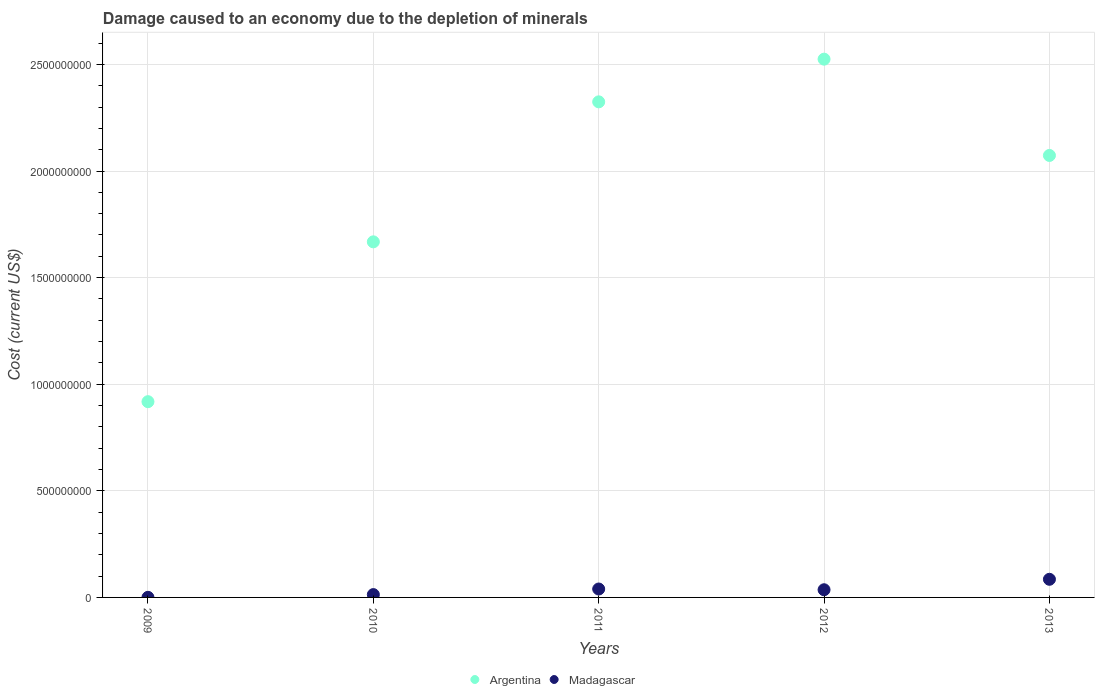What is the cost of damage caused due to the depletion of minerals in Madagascar in 2009?
Offer a terse response. 4.19e+05. Across all years, what is the maximum cost of damage caused due to the depletion of minerals in Madagascar?
Your answer should be very brief. 8.50e+07. Across all years, what is the minimum cost of damage caused due to the depletion of minerals in Argentina?
Your answer should be compact. 9.18e+08. In which year was the cost of damage caused due to the depletion of minerals in Argentina maximum?
Your answer should be compact. 2012. In which year was the cost of damage caused due to the depletion of minerals in Madagascar minimum?
Your answer should be very brief. 2009. What is the total cost of damage caused due to the depletion of minerals in Madagascar in the graph?
Your response must be concise. 1.74e+08. What is the difference between the cost of damage caused due to the depletion of minerals in Argentina in 2009 and that in 2013?
Your answer should be very brief. -1.15e+09. What is the difference between the cost of damage caused due to the depletion of minerals in Madagascar in 2010 and the cost of damage caused due to the depletion of minerals in Argentina in 2009?
Ensure brevity in your answer.  -9.05e+08. What is the average cost of damage caused due to the depletion of minerals in Madagascar per year?
Your response must be concise. 3.48e+07. In the year 2009, what is the difference between the cost of damage caused due to the depletion of minerals in Madagascar and cost of damage caused due to the depletion of minerals in Argentina?
Ensure brevity in your answer.  -9.18e+08. In how many years, is the cost of damage caused due to the depletion of minerals in Argentina greater than 2200000000 US$?
Your response must be concise. 2. What is the ratio of the cost of damage caused due to the depletion of minerals in Argentina in 2009 to that in 2011?
Your response must be concise. 0.39. Is the difference between the cost of damage caused due to the depletion of minerals in Madagascar in 2011 and 2013 greater than the difference between the cost of damage caused due to the depletion of minerals in Argentina in 2011 and 2013?
Give a very brief answer. No. What is the difference between the highest and the second highest cost of damage caused due to the depletion of minerals in Argentina?
Ensure brevity in your answer.  2.00e+08. What is the difference between the highest and the lowest cost of damage caused due to the depletion of minerals in Madagascar?
Make the answer very short. 8.46e+07. Is the sum of the cost of damage caused due to the depletion of minerals in Argentina in 2009 and 2011 greater than the maximum cost of damage caused due to the depletion of minerals in Madagascar across all years?
Offer a terse response. Yes. Does the cost of damage caused due to the depletion of minerals in Madagascar monotonically increase over the years?
Offer a very short reply. No. Is the cost of damage caused due to the depletion of minerals in Madagascar strictly less than the cost of damage caused due to the depletion of minerals in Argentina over the years?
Give a very brief answer. Yes. What is the difference between two consecutive major ticks on the Y-axis?
Your answer should be very brief. 5.00e+08. Does the graph contain grids?
Offer a terse response. Yes. What is the title of the graph?
Offer a very short reply. Damage caused to an economy due to the depletion of minerals. What is the label or title of the Y-axis?
Your answer should be very brief. Cost (current US$). What is the Cost (current US$) in Argentina in 2009?
Make the answer very short. 9.18e+08. What is the Cost (current US$) of Madagascar in 2009?
Provide a short and direct response. 4.19e+05. What is the Cost (current US$) of Argentina in 2010?
Keep it short and to the point. 1.67e+09. What is the Cost (current US$) of Madagascar in 2010?
Keep it short and to the point. 1.33e+07. What is the Cost (current US$) of Argentina in 2011?
Provide a short and direct response. 2.32e+09. What is the Cost (current US$) in Madagascar in 2011?
Keep it short and to the point. 3.95e+07. What is the Cost (current US$) in Argentina in 2012?
Provide a short and direct response. 2.52e+09. What is the Cost (current US$) of Madagascar in 2012?
Your answer should be very brief. 3.60e+07. What is the Cost (current US$) of Argentina in 2013?
Make the answer very short. 2.07e+09. What is the Cost (current US$) of Madagascar in 2013?
Make the answer very short. 8.50e+07. Across all years, what is the maximum Cost (current US$) in Argentina?
Ensure brevity in your answer.  2.52e+09. Across all years, what is the maximum Cost (current US$) in Madagascar?
Offer a very short reply. 8.50e+07. Across all years, what is the minimum Cost (current US$) in Argentina?
Ensure brevity in your answer.  9.18e+08. Across all years, what is the minimum Cost (current US$) of Madagascar?
Provide a short and direct response. 4.19e+05. What is the total Cost (current US$) of Argentina in the graph?
Your answer should be very brief. 9.51e+09. What is the total Cost (current US$) in Madagascar in the graph?
Offer a very short reply. 1.74e+08. What is the difference between the Cost (current US$) in Argentina in 2009 and that in 2010?
Offer a terse response. -7.50e+08. What is the difference between the Cost (current US$) of Madagascar in 2009 and that in 2010?
Ensure brevity in your answer.  -1.29e+07. What is the difference between the Cost (current US$) of Argentina in 2009 and that in 2011?
Offer a very short reply. -1.41e+09. What is the difference between the Cost (current US$) of Madagascar in 2009 and that in 2011?
Provide a short and direct response. -3.91e+07. What is the difference between the Cost (current US$) of Argentina in 2009 and that in 2012?
Offer a very short reply. -1.61e+09. What is the difference between the Cost (current US$) in Madagascar in 2009 and that in 2012?
Offer a very short reply. -3.56e+07. What is the difference between the Cost (current US$) of Argentina in 2009 and that in 2013?
Provide a short and direct response. -1.15e+09. What is the difference between the Cost (current US$) of Madagascar in 2009 and that in 2013?
Provide a short and direct response. -8.46e+07. What is the difference between the Cost (current US$) of Argentina in 2010 and that in 2011?
Ensure brevity in your answer.  -6.57e+08. What is the difference between the Cost (current US$) of Madagascar in 2010 and that in 2011?
Provide a succinct answer. -2.62e+07. What is the difference between the Cost (current US$) of Argentina in 2010 and that in 2012?
Offer a terse response. -8.57e+08. What is the difference between the Cost (current US$) of Madagascar in 2010 and that in 2012?
Make the answer very short. -2.27e+07. What is the difference between the Cost (current US$) in Argentina in 2010 and that in 2013?
Offer a terse response. -4.05e+08. What is the difference between the Cost (current US$) of Madagascar in 2010 and that in 2013?
Your answer should be very brief. -7.18e+07. What is the difference between the Cost (current US$) of Argentina in 2011 and that in 2012?
Your answer should be compact. -2.00e+08. What is the difference between the Cost (current US$) in Madagascar in 2011 and that in 2012?
Your response must be concise. 3.46e+06. What is the difference between the Cost (current US$) of Argentina in 2011 and that in 2013?
Provide a succinct answer. 2.51e+08. What is the difference between the Cost (current US$) in Madagascar in 2011 and that in 2013?
Offer a terse response. -4.56e+07. What is the difference between the Cost (current US$) in Argentina in 2012 and that in 2013?
Ensure brevity in your answer.  4.52e+08. What is the difference between the Cost (current US$) in Madagascar in 2012 and that in 2013?
Offer a very short reply. -4.90e+07. What is the difference between the Cost (current US$) of Argentina in 2009 and the Cost (current US$) of Madagascar in 2010?
Keep it short and to the point. 9.05e+08. What is the difference between the Cost (current US$) of Argentina in 2009 and the Cost (current US$) of Madagascar in 2011?
Offer a terse response. 8.79e+08. What is the difference between the Cost (current US$) of Argentina in 2009 and the Cost (current US$) of Madagascar in 2012?
Provide a succinct answer. 8.82e+08. What is the difference between the Cost (current US$) in Argentina in 2009 and the Cost (current US$) in Madagascar in 2013?
Keep it short and to the point. 8.33e+08. What is the difference between the Cost (current US$) of Argentina in 2010 and the Cost (current US$) of Madagascar in 2011?
Give a very brief answer. 1.63e+09. What is the difference between the Cost (current US$) of Argentina in 2010 and the Cost (current US$) of Madagascar in 2012?
Offer a very short reply. 1.63e+09. What is the difference between the Cost (current US$) in Argentina in 2010 and the Cost (current US$) in Madagascar in 2013?
Give a very brief answer. 1.58e+09. What is the difference between the Cost (current US$) in Argentina in 2011 and the Cost (current US$) in Madagascar in 2012?
Ensure brevity in your answer.  2.29e+09. What is the difference between the Cost (current US$) of Argentina in 2011 and the Cost (current US$) of Madagascar in 2013?
Provide a succinct answer. 2.24e+09. What is the difference between the Cost (current US$) of Argentina in 2012 and the Cost (current US$) of Madagascar in 2013?
Offer a terse response. 2.44e+09. What is the average Cost (current US$) in Argentina per year?
Your answer should be compact. 1.90e+09. What is the average Cost (current US$) in Madagascar per year?
Keep it short and to the point. 3.48e+07. In the year 2009, what is the difference between the Cost (current US$) in Argentina and Cost (current US$) in Madagascar?
Your response must be concise. 9.18e+08. In the year 2010, what is the difference between the Cost (current US$) in Argentina and Cost (current US$) in Madagascar?
Provide a short and direct response. 1.65e+09. In the year 2011, what is the difference between the Cost (current US$) of Argentina and Cost (current US$) of Madagascar?
Keep it short and to the point. 2.29e+09. In the year 2012, what is the difference between the Cost (current US$) of Argentina and Cost (current US$) of Madagascar?
Provide a succinct answer. 2.49e+09. In the year 2013, what is the difference between the Cost (current US$) in Argentina and Cost (current US$) in Madagascar?
Make the answer very short. 1.99e+09. What is the ratio of the Cost (current US$) of Argentina in 2009 to that in 2010?
Your response must be concise. 0.55. What is the ratio of the Cost (current US$) of Madagascar in 2009 to that in 2010?
Provide a succinct answer. 0.03. What is the ratio of the Cost (current US$) in Argentina in 2009 to that in 2011?
Offer a very short reply. 0.4. What is the ratio of the Cost (current US$) in Madagascar in 2009 to that in 2011?
Give a very brief answer. 0.01. What is the ratio of the Cost (current US$) of Argentina in 2009 to that in 2012?
Give a very brief answer. 0.36. What is the ratio of the Cost (current US$) of Madagascar in 2009 to that in 2012?
Your response must be concise. 0.01. What is the ratio of the Cost (current US$) in Argentina in 2009 to that in 2013?
Provide a succinct answer. 0.44. What is the ratio of the Cost (current US$) in Madagascar in 2009 to that in 2013?
Provide a succinct answer. 0. What is the ratio of the Cost (current US$) of Argentina in 2010 to that in 2011?
Offer a very short reply. 0.72. What is the ratio of the Cost (current US$) in Madagascar in 2010 to that in 2011?
Your answer should be compact. 0.34. What is the ratio of the Cost (current US$) of Argentina in 2010 to that in 2012?
Offer a very short reply. 0.66. What is the ratio of the Cost (current US$) of Madagascar in 2010 to that in 2012?
Keep it short and to the point. 0.37. What is the ratio of the Cost (current US$) of Argentina in 2010 to that in 2013?
Keep it short and to the point. 0.8. What is the ratio of the Cost (current US$) of Madagascar in 2010 to that in 2013?
Keep it short and to the point. 0.16. What is the ratio of the Cost (current US$) of Argentina in 2011 to that in 2012?
Ensure brevity in your answer.  0.92. What is the ratio of the Cost (current US$) in Madagascar in 2011 to that in 2012?
Your response must be concise. 1.1. What is the ratio of the Cost (current US$) in Argentina in 2011 to that in 2013?
Give a very brief answer. 1.12. What is the ratio of the Cost (current US$) in Madagascar in 2011 to that in 2013?
Make the answer very short. 0.46. What is the ratio of the Cost (current US$) of Argentina in 2012 to that in 2013?
Give a very brief answer. 1.22. What is the ratio of the Cost (current US$) in Madagascar in 2012 to that in 2013?
Keep it short and to the point. 0.42. What is the difference between the highest and the second highest Cost (current US$) in Argentina?
Your response must be concise. 2.00e+08. What is the difference between the highest and the second highest Cost (current US$) of Madagascar?
Ensure brevity in your answer.  4.56e+07. What is the difference between the highest and the lowest Cost (current US$) of Argentina?
Give a very brief answer. 1.61e+09. What is the difference between the highest and the lowest Cost (current US$) in Madagascar?
Give a very brief answer. 8.46e+07. 